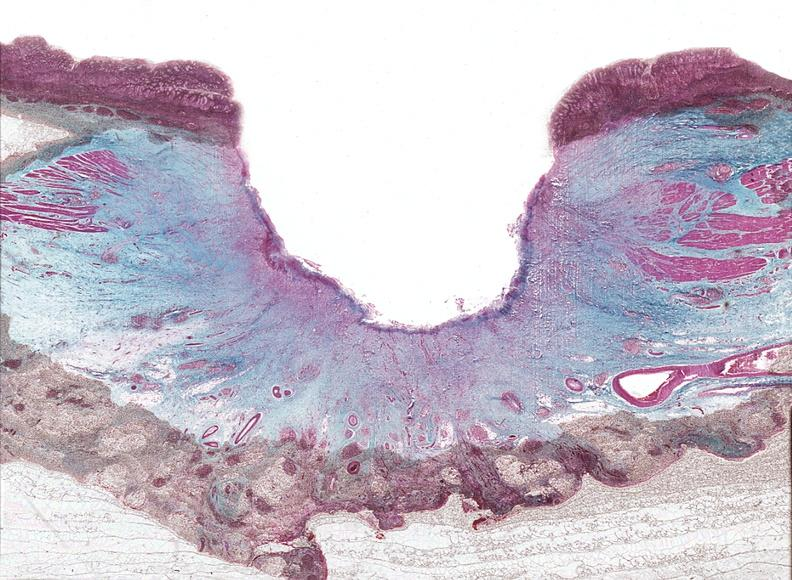what does this image show?
Answer the question using a single word or phrase. Stomach 